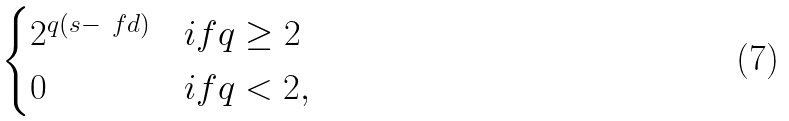Convert formula to latex. <formula><loc_0><loc_0><loc_500><loc_500>\begin{cases} 2 ^ { q ( s - \ f d ) } & i f q \geq 2 \\ 0 & i f q < 2 , \end{cases}</formula> 